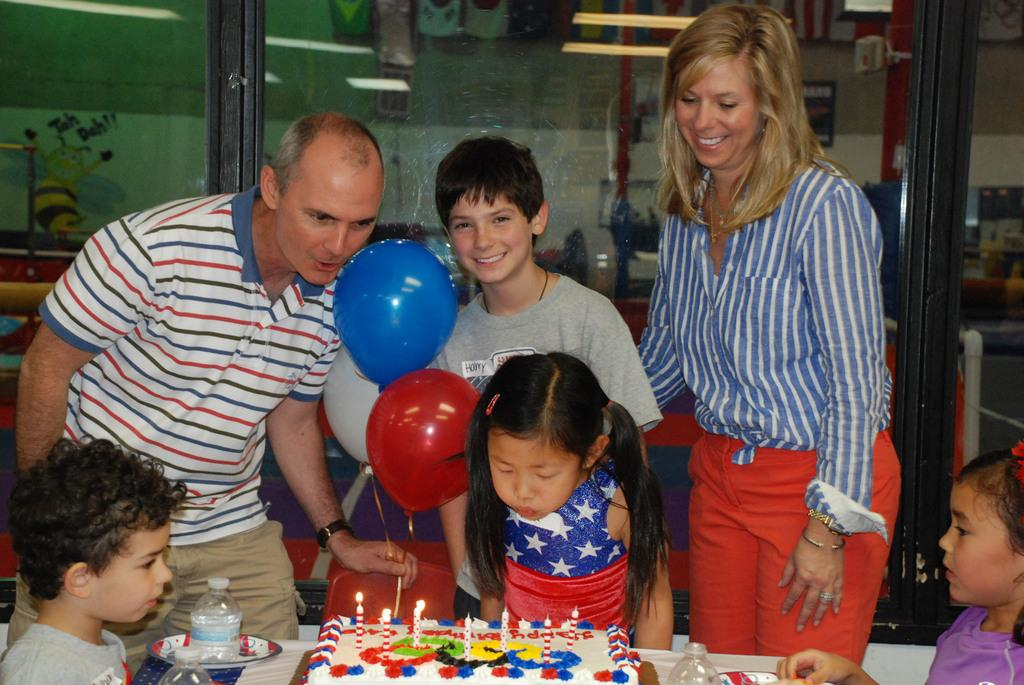How many people are present in the image? There are two persons in the image. How many children are present in the image? There are four children in the image. What can be seen on the table in the image? There is a cake on a table in the image. What is the opinion of the fireman about the cake in the image? There is no fireman present in the image, so it is not possible to determine their opinion about the cake. 